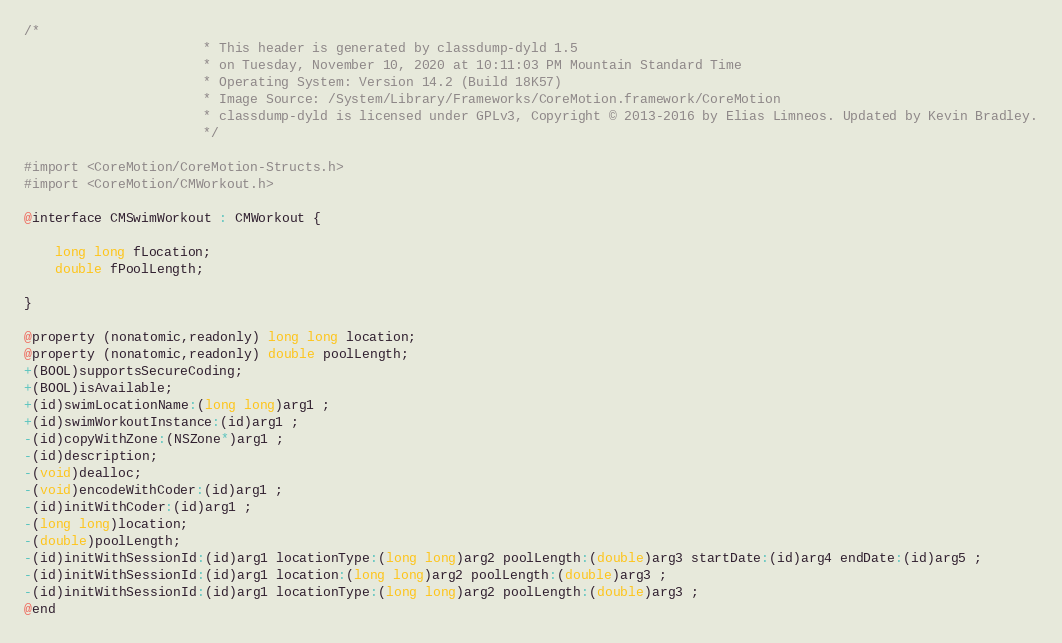<code> <loc_0><loc_0><loc_500><loc_500><_C_>/*
                       * This header is generated by classdump-dyld 1.5
                       * on Tuesday, November 10, 2020 at 10:11:03 PM Mountain Standard Time
                       * Operating System: Version 14.2 (Build 18K57)
                       * Image Source: /System/Library/Frameworks/CoreMotion.framework/CoreMotion
                       * classdump-dyld is licensed under GPLv3, Copyright © 2013-2016 by Elias Limneos. Updated by Kevin Bradley.
                       */

#import <CoreMotion/CoreMotion-Structs.h>
#import <CoreMotion/CMWorkout.h>

@interface CMSwimWorkout : CMWorkout {

	long long fLocation;
	double fPoolLength;

}

@property (nonatomic,readonly) long long location; 
@property (nonatomic,readonly) double poolLength; 
+(BOOL)supportsSecureCoding;
+(BOOL)isAvailable;
+(id)swimLocationName:(long long)arg1 ;
+(id)swimWorkoutInstance:(id)arg1 ;
-(id)copyWithZone:(NSZone*)arg1 ;
-(id)description;
-(void)dealloc;
-(void)encodeWithCoder:(id)arg1 ;
-(id)initWithCoder:(id)arg1 ;
-(long long)location;
-(double)poolLength;
-(id)initWithSessionId:(id)arg1 locationType:(long long)arg2 poolLength:(double)arg3 startDate:(id)arg4 endDate:(id)arg5 ;
-(id)initWithSessionId:(id)arg1 location:(long long)arg2 poolLength:(double)arg3 ;
-(id)initWithSessionId:(id)arg1 locationType:(long long)arg2 poolLength:(double)arg3 ;
@end

</code> 